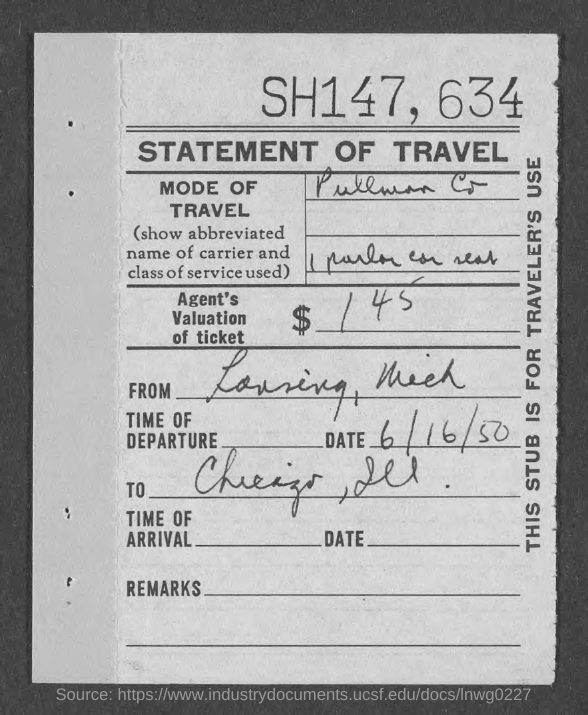Give some essential details in this illustration. The date of departure is June 16, 1950. This stub is intended for the use of a traveler. The Pullman Company is the mode of transportation. 